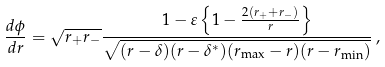Convert formula to latex. <formula><loc_0><loc_0><loc_500><loc_500>\frac { d \phi } { d r } = \sqrt { r _ { + } r _ { - } } \frac { 1 - \varepsilon \left \{ 1 - \frac { 2 ( r _ { + } + r _ { - } ) } { r } \right \} } { \sqrt { ( r - \delta ) ( r - \delta ^ { * } ) ( r _ { \max } - r ) ( r - r _ { \min } ) } } \, ,</formula> 